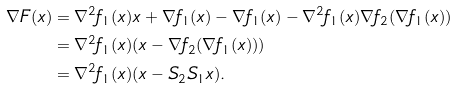<formula> <loc_0><loc_0><loc_500><loc_500>\nabla F ( x ) & = \nabla ^ { 2 } f _ { 1 } ( x ) x + \nabla f _ { 1 } ( x ) - \nabla f _ { 1 } ( x ) - \nabla ^ { 2 } f _ { 1 } ( x ) \nabla f _ { 2 } ( \nabla f _ { 1 } ( x ) ) \\ & = \nabla ^ { 2 } f _ { 1 } ( x ) ( x - \nabla f _ { 2 } ( \nabla f _ { 1 } ( x ) ) ) \\ & = \nabla ^ { 2 } f _ { 1 } ( x ) ( x - S _ { 2 } S _ { 1 } x ) .</formula> 